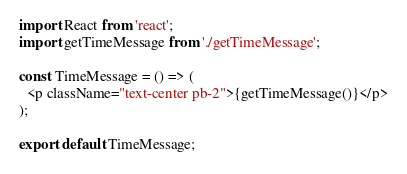Convert code to text. <code><loc_0><loc_0><loc_500><loc_500><_JavaScript_>import React from 'react';
import getTimeMessage from './getTimeMessage';

const TimeMessage = () => (
  <p className="text-center pb-2">{getTimeMessage()}</p>
);

export default TimeMessage;
</code> 